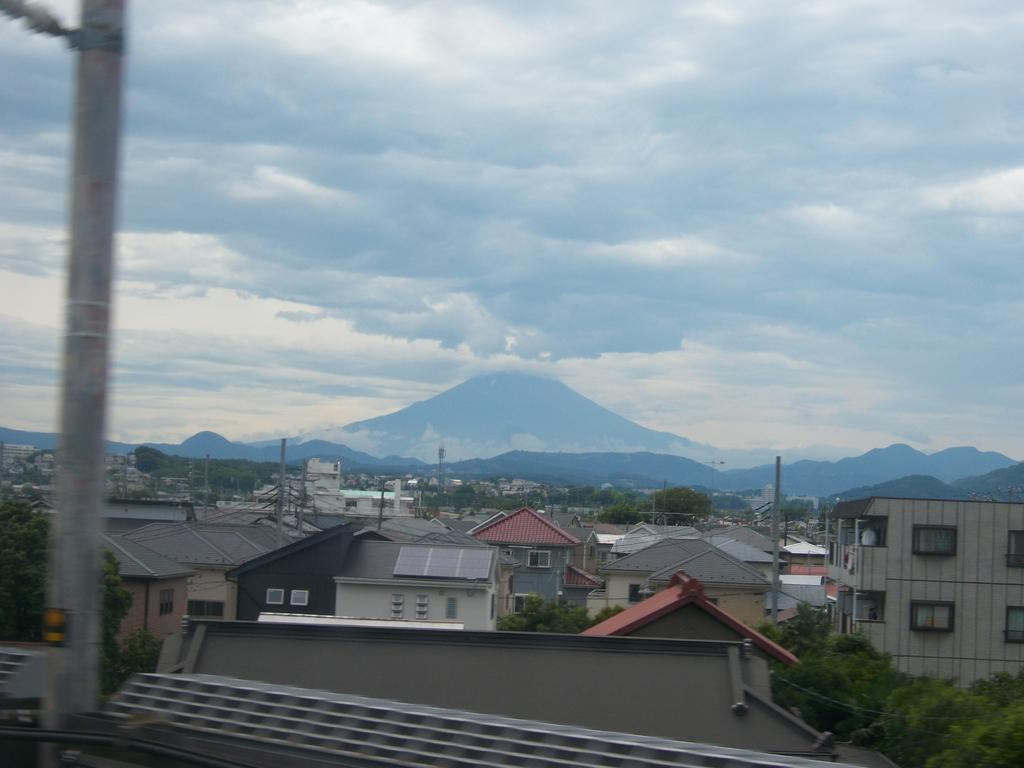What type of structures can be seen in the image? There are buildings in the image. What else can be seen in the image besides buildings? There are poles and trees visible in the image. What is visible in the background of the image? There are mountains and the sky visible in the background of the image. What can be observed in the sky in the image? Clouds are present in the sky in the image. How does the impulse affect the trees in the image? There is no mention of an impulse in the image, and therefore its effect on the trees cannot be determined. 